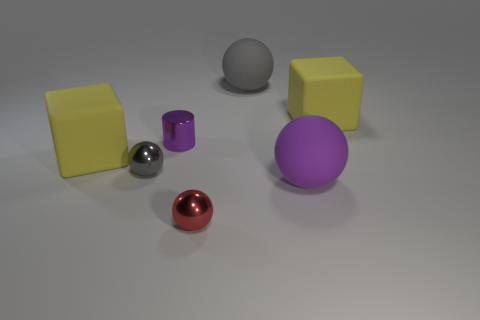Subtract all small gray balls. How many balls are left? 3 Subtract all blue blocks. How many gray spheres are left? 2 Add 2 big brown spheres. How many objects exist? 9 Subtract all purple spheres. How many spheres are left? 3 Subtract all blue cubes. Subtract all gray spheres. How many cubes are left? 2 Subtract all large gray matte things. Subtract all yellow rubber blocks. How many objects are left? 4 Add 6 gray metal things. How many gray metal things are left? 7 Add 5 small spheres. How many small spheres exist? 7 Subtract 0 brown balls. How many objects are left? 7 Subtract all cylinders. How many objects are left? 6 